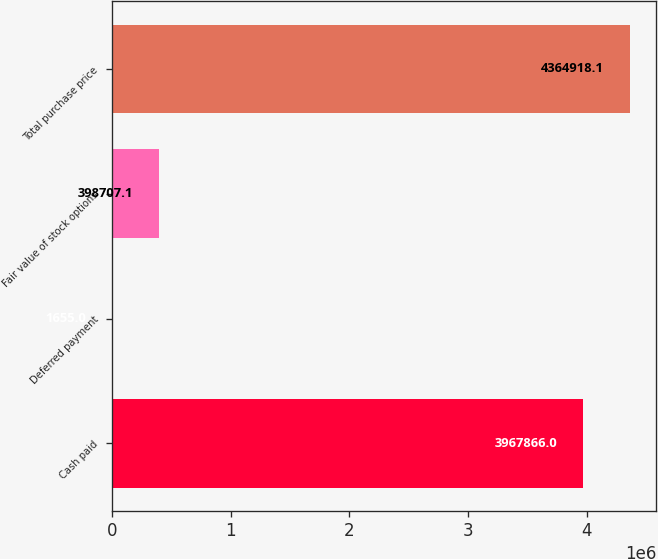<chart> <loc_0><loc_0><loc_500><loc_500><bar_chart><fcel>Cash paid<fcel>Deferred payment<fcel>Fair value of stock options<fcel>Total purchase price<nl><fcel>3.96787e+06<fcel>1655<fcel>398707<fcel>4.36492e+06<nl></chart> 